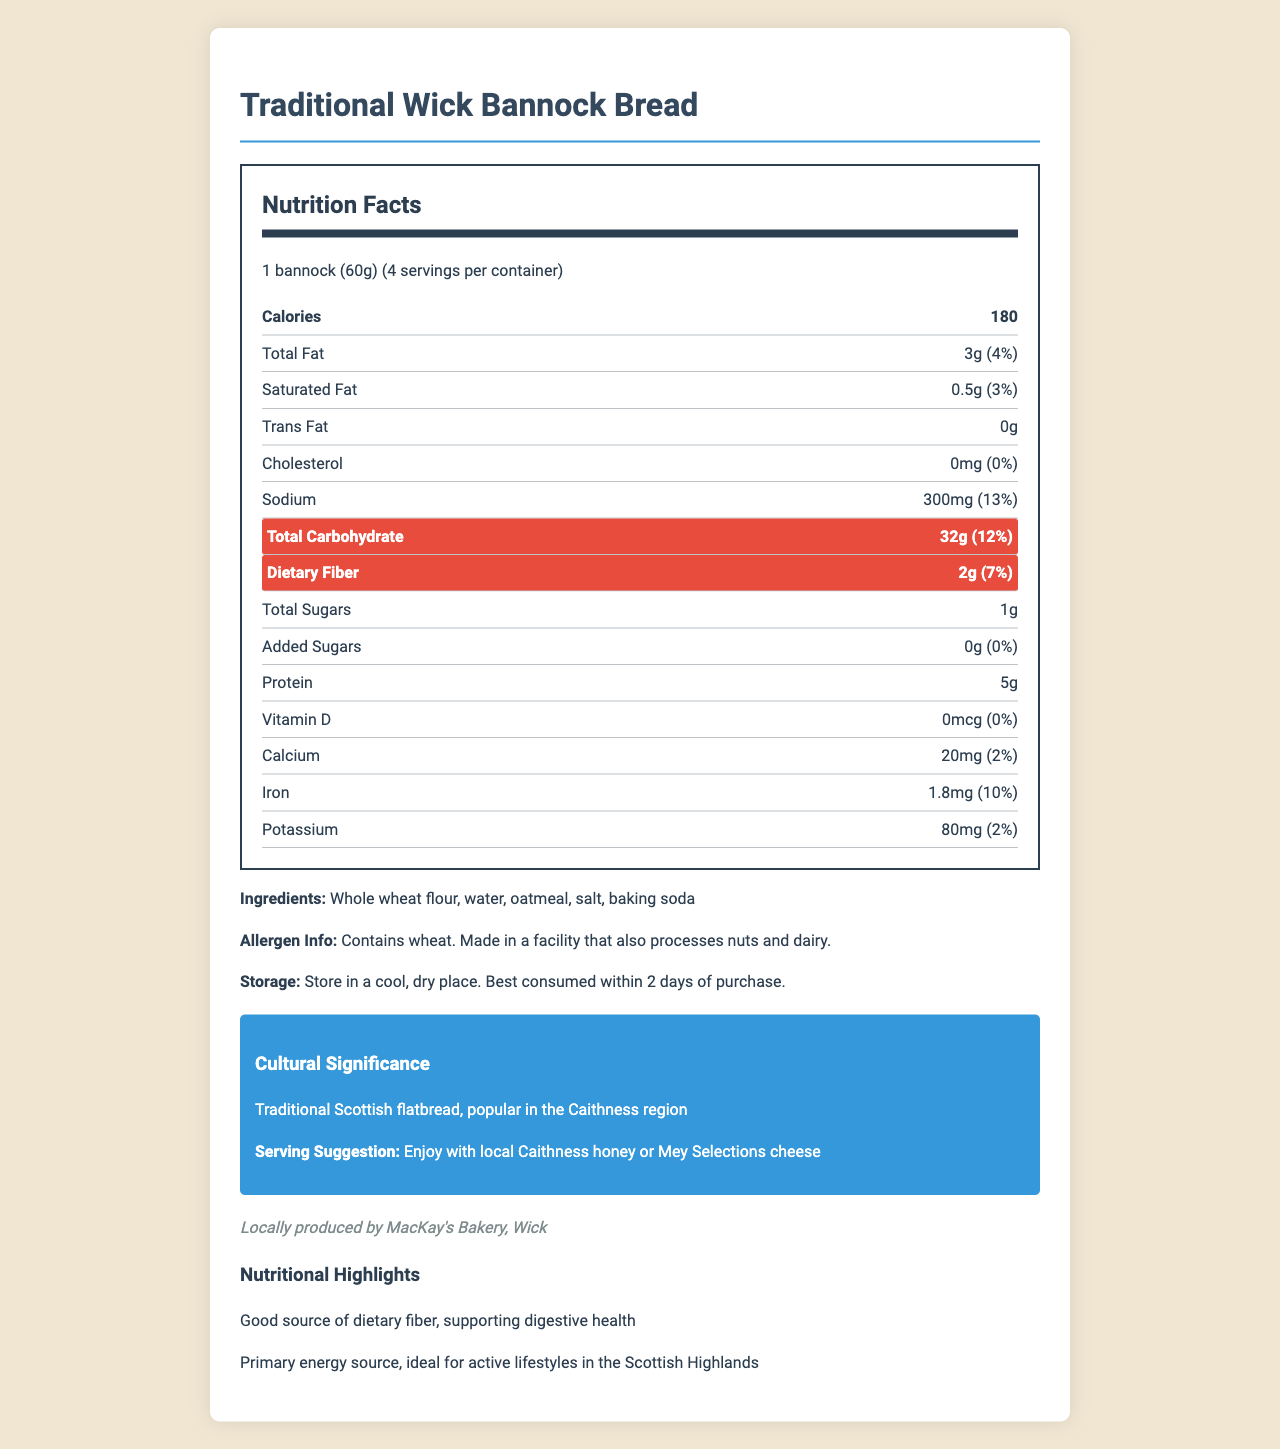what is the serving size for Traditional Wick Bannock Bread? The serving size is clearly listed in the document as "1 bannock (60g)."
Answer: 1 bannock (60g) how many calories are there per serving? The document states that each serving contains 180 calories.
Answer: 180 how much dietary fiber does one serving provide? According to the document, one serving of Traditional Wick Bannock Bread provides 2 grams of dietary fiber.
Answer: 2g what is the daily value percentage of total carbohydrate per serving? The daily value percentage for total carbohydrate is mentioned as 12% per serving.
Answer: 12% can you list the main ingredients in Traditional Wick Bannock Bread? The document lists the main ingredients as "Whole wheat flour, water, oatmeal, salt, baking soda."
Answer: Whole wheat flour, water, oatmeal, salt, baking soda how much protein is in one serving of Traditional Wick Bannock Bread? A. 3g B. 5g C. 7g D. 9g The document specifies that each serving contains 5 grams of protein.
Answer: B. 5g what is the cholesterol content in one serving? A. 0mg B. 10mg C. 20mg D. 30mg The document clearly indicates that the cholesterol content per serving is 0mg.
Answer: A. 0mg does Traditional Wick Bannock Bread contain any trans fat? The document states that the trans fat content is 0g, which means it does not contain any trans fat.
Answer: No is there any added sugar in the Traditional Wick Bannock Bread? The document states that the amount of added sugars is 0g, indicating there are no added sugars.
Answer: No is Traditional Wick Bannock Bread a good source of dietary fiber? The document notes that it is a good source of dietary fiber, supporting digestive health.
Answer: Yes summarize the main nutritional benefits of Traditional Wick Bannock Bread. The document highlights that the bread is a good source of dietary fiber, supports digestive health, and is an ideal source of energy due to its carbohydrate content.
Answer: Traditional Wick Bannock Bread provides a balanced source of energy with 180 calories per serving, is low in saturated fat and cholesterol-free, contains 32g of carbohydrates, 2g of dietary fiber, and 5g of protein, making it suitable for active lifestyles. what is the exact percentage of daily iron intake provided by one serving? The document lists the daily value percentage for iron as 10% per serving.
Answer: 10% what are the storage instructions for Traditional Wick Bannock Bread? The storage instructions are explicitly mentioned: store in a cool, dry place, and it is best consumed within 2 days of purchase.
Answer: Store in a cool, dry place. Best consumed within 2 days of purchase. who produces Traditional Wick Bannock Bread locally? The document states that the bread is locally produced by MacKay's Bakery in Wick.
Answer: MacKay's Bakery, Wick why is Traditional Wick Bannock Bread culturally significant? The document notes the cultural significance as a traditional Scottish flatbread that is popular in the Caithness region.
Answer: It is a traditional Scottish flatbread, popular in the Caithness region. what allergens are present in Traditional Wick Bannock Bread? The document provides allergen information, stating that it contains wheat and is made in a facility that also processes nuts and dairy.
Answer: Contains wheat. Made in a facility that also processes nuts and dairy. how many servings are there per container? The document specifies that there are 4 servings per container.
Answer: 4 what amount of potassium does one serving contain? The document lists the potassium content as 80mg per serving.
Answer: 80mg what is the total daily value percentage for calcium in one serving? The daily value percentage for calcium is mentioned as 2% per serving.
Answer: 2% what activity is Traditional Wick Bannock Bread ideal for? The document notes that the bread's carbohydrate content makes it ideal for active lifestyles in the Scottish Highlands.
Answer: Ideal for active lifestyles in the Scottish Highlands how many grams of total sugars does one serving contain? The document states that each serving contains 1 gram of total sugars.
Answer: 1g what is the protein source in Traditional Wick Bannock Bread? The document specifies the protein content but doesn't detail which ingredient(s) provide it.
Answer: Not enough information 